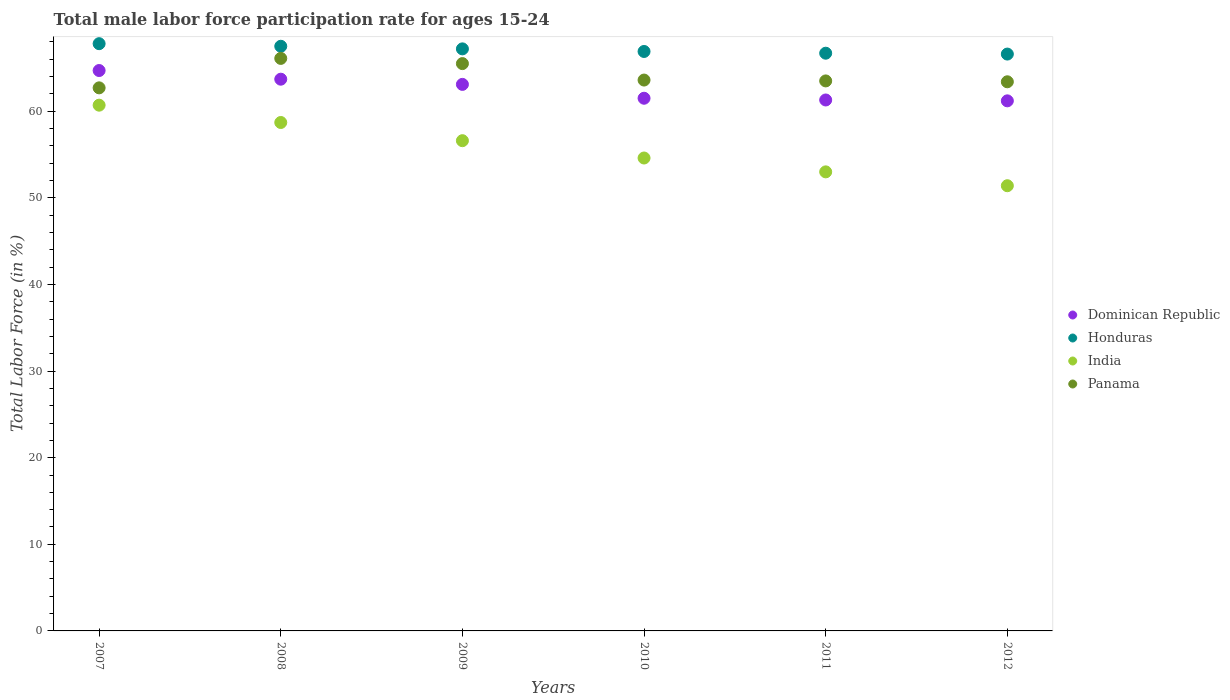How many different coloured dotlines are there?
Your response must be concise. 4. What is the male labor force participation rate in Panama in 2010?
Provide a short and direct response. 63.6. Across all years, what is the maximum male labor force participation rate in Dominican Republic?
Offer a very short reply. 64.7. Across all years, what is the minimum male labor force participation rate in Honduras?
Your answer should be compact. 66.6. In which year was the male labor force participation rate in Honduras maximum?
Offer a terse response. 2007. In which year was the male labor force participation rate in Dominican Republic minimum?
Your answer should be compact. 2012. What is the total male labor force participation rate in Panama in the graph?
Offer a very short reply. 384.8. What is the difference between the male labor force participation rate in Honduras in 2009 and that in 2010?
Your answer should be compact. 0.3. What is the difference between the male labor force participation rate in India in 2009 and the male labor force participation rate in Honduras in 2007?
Make the answer very short. -11.2. What is the average male labor force participation rate in Dominican Republic per year?
Provide a short and direct response. 62.58. In the year 2011, what is the difference between the male labor force participation rate in India and male labor force participation rate in Honduras?
Offer a very short reply. -13.7. In how many years, is the male labor force participation rate in Dominican Republic greater than 6 %?
Keep it short and to the point. 6. What is the ratio of the male labor force participation rate in Dominican Republic in 2008 to that in 2011?
Make the answer very short. 1.04. Is the male labor force participation rate in Dominican Republic in 2007 less than that in 2012?
Offer a very short reply. No. Is the difference between the male labor force participation rate in India in 2008 and 2012 greater than the difference between the male labor force participation rate in Honduras in 2008 and 2012?
Provide a short and direct response. Yes. What is the difference between the highest and the second highest male labor force participation rate in India?
Keep it short and to the point. 2. What is the difference between the highest and the lowest male labor force participation rate in Dominican Republic?
Give a very brief answer. 3.5. In how many years, is the male labor force participation rate in Honduras greater than the average male labor force participation rate in Honduras taken over all years?
Keep it short and to the point. 3. Does the male labor force participation rate in Panama monotonically increase over the years?
Offer a terse response. No. Is the male labor force participation rate in India strictly greater than the male labor force participation rate in Panama over the years?
Provide a succinct answer. No. How many years are there in the graph?
Keep it short and to the point. 6. What is the difference between two consecutive major ticks on the Y-axis?
Give a very brief answer. 10. Are the values on the major ticks of Y-axis written in scientific E-notation?
Offer a very short reply. No. Does the graph contain any zero values?
Make the answer very short. No. Does the graph contain grids?
Provide a short and direct response. No. Where does the legend appear in the graph?
Give a very brief answer. Center right. How many legend labels are there?
Your answer should be very brief. 4. What is the title of the graph?
Keep it short and to the point. Total male labor force participation rate for ages 15-24. What is the label or title of the Y-axis?
Offer a very short reply. Total Labor Force (in %). What is the Total Labor Force (in %) of Dominican Republic in 2007?
Keep it short and to the point. 64.7. What is the Total Labor Force (in %) in Honduras in 2007?
Keep it short and to the point. 67.8. What is the Total Labor Force (in %) of India in 2007?
Make the answer very short. 60.7. What is the Total Labor Force (in %) of Panama in 2007?
Your answer should be very brief. 62.7. What is the Total Labor Force (in %) of Dominican Republic in 2008?
Offer a very short reply. 63.7. What is the Total Labor Force (in %) in Honduras in 2008?
Give a very brief answer. 67.5. What is the Total Labor Force (in %) in India in 2008?
Give a very brief answer. 58.7. What is the Total Labor Force (in %) in Panama in 2008?
Your answer should be very brief. 66.1. What is the Total Labor Force (in %) in Dominican Republic in 2009?
Your answer should be very brief. 63.1. What is the Total Labor Force (in %) of Honduras in 2009?
Keep it short and to the point. 67.2. What is the Total Labor Force (in %) of India in 2009?
Your response must be concise. 56.6. What is the Total Labor Force (in %) of Panama in 2009?
Make the answer very short. 65.5. What is the Total Labor Force (in %) of Dominican Republic in 2010?
Offer a very short reply. 61.5. What is the Total Labor Force (in %) of Honduras in 2010?
Your answer should be very brief. 66.9. What is the Total Labor Force (in %) in India in 2010?
Provide a succinct answer. 54.6. What is the Total Labor Force (in %) in Panama in 2010?
Your answer should be compact. 63.6. What is the Total Labor Force (in %) in Dominican Republic in 2011?
Offer a terse response. 61.3. What is the Total Labor Force (in %) of Honduras in 2011?
Keep it short and to the point. 66.7. What is the Total Labor Force (in %) of India in 2011?
Give a very brief answer. 53. What is the Total Labor Force (in %) in Panama in 2011?
Provide a short and direct response. 63.5. What is the Total Labor Force (in %) of Dominican Republic in 2012?
Your response must be concise. 61.2. What is the Total Labor Force (in %) of Honduras in 2012?
Make the answer very short. 66.6. What is the Total Labor Force (in %) of India in 2012?
Ensure brevity in your answer.  51.4. What is the Total Labor Force (in %) in Panama in 2012?
Offer a very short reply. 63.4. Across all years, what is the maximum Total Labor Force (in %) of Dominican Republic?
Ensure brevity in your answer.  64.7. Across all years, what is the maximum Total Labor Force (in %) in Honduras?
Offer a terse response. 67.8. Across all years, what is the maximum Total Labor Force (in %) in India?
Keep it short and to the point. 60.7. Across all years, what is the maximum Total Labor Force (in %) in Panama?
Provide a short and direct response. 66.1. Across all years, what is the minimum Total Labor Force (in %) in Dominican Republic?
Provide a short and direct response. 61.2. Across all years, what is the minimum Total Labor Force (in %) in Honduras?
Give a very brief answer. 66.6. Across all years, what is the minimum Total Labor Force (in %) in India?
Provide a succinct answer. 51.4. Across all years, what is the minimum Total Labor Force (in %) of Panama?
Ensure brevity in your answer.  62.7. What is the total Total Labor Force (in %) in Dominican Republic in the graph?
Your answer should be very brief. 375.5. What is the total Total Labor Force (in %) in Honduras in the graph?
Your response must be concise. 402.7. What is the total Total Labor Force (in %) in India in the graph?
Your answer should be very brief. 335. What is the total Total Labor Force (in %) of Panama in the graph?
Your answer should be compact. 384.8. What is the difference between the Total Labor Force (in %) in Honduras in 2007 and that in 2008?
Your answer should be very brief. 0.3. What is the difference between the Total Labor Force (in %) in Honduras in 2007 and that in 2009?
Keep it short and to the point. 0.6. What is the difference between the Total Labor Force (in %) in Panama in 2007 and that in 2009?
Give a very brief answer. -2.8. What is the difference between the Total Labor Force (in %) in Dominican Republic in 2007 and that in 2010?
Provide a short and direct response. 3.2. What is the difference between the Total Labor Force (in %) of Honduras in 2007 and that in 2010?
Ensure brevity in your answer.  0.9. What is the difference between the Total Labor Force (in %) in Panama in 2007 and that in 2010?
Give a very brief answer. -0.9. What is the difference between the Total Labor Force (in %) of Dominican Republic in 2007 and that in 2011?
Give a very brief answer. 3.4. What is the difference between the Total Labor Force (in %) in India in 2007 and that in 2011?
Give a very brief answer. 7.7. What is the difference between the Total Labor Force (in %) in Panama in 2007 and that in 2011?
Keep it short and to the point. -0.8. What is the difference between the Total Labor Force (in %) of Dominican Republic in 2007 and that in 2012?
Offer a terse response. 3.5. What is the difference between the Total Labor Force (in %) in Honduras in 2007 and that in 2012?
Your response must be concise. 1.2. What is the difference between the Total Labor Force (in %) of India in 2007 and that in 2012?
Your response must be concise. 9.3. What is the difference between the Total Labor Force (in %) of Panama in 2007 and that in 2012?
Give a very brief answer. -0.7. What is the difference between the Total Labor Force (in %) of Honduras in 2008 and that in 2009?
Offer a very short reply. 0.3. What is the difference between the Total Labor Force (in %) in India in 2008 and that in 2009?
Your answer should be compact. 2.1. What is the difference between the Total Labor Force (in %) in Dominican Republic in 2008 and that in 2010?
Offer a terse response. 2.2. What is the difference between the Total Labor Force (in %) in India in 2008 and that in 2010?
Keep it short and to the point. 4.1. What is the difference between the Total Labor Force (in %) in Panama in 2008 and that in 2010?
Ensure brevity in your answer.  2.5. What is the difference between the Total Labor Force (in %) in Honduras in 2008 and that in 2011?
Your response must be concise. 0.8. What is the difference between the Total Labor Force (in %) in India in 2008 and that in 2011?
Offer a terse response. 5.7. What is the difference between the Total Labor Force (in %) in Panama in 2008 and that in 2011?
Ensure brevity in your answer.  2.6. What is the difference between the Total Labor Force (in %) of Dominican Republic in 2008 and that in 2012?
Keep it short and to the point. 2.5. What is the difference between the Total Labor Force (in %) of Panama in 2008 and that in 2012?
Give a very brief answer. 2.7. What is the difference between the Total Labor Force (in %) of Dominican Republic in 2009 and that in 2010?
Provide a succinct answer. 1.6. What is the difference between the Total Labor Force (in %) of India in 2009 and that in 2010?
Your answer should be compact. 2. What is the difference between the Total Labor Force (in %) of Dominican Republic in 2009 and that in 2011?
Make the answer very short. 1.8. What is the difference between the Total Labor Force (in %) of Dominican Republic in 2009 and that in 2012?
Provide a short and direct response. 1.9. What is the difference between the Total Labor Force (in %) in Honduras in 2009 and that in 2012?
Provide a short and direct response. 0.6. What is the difference between the Total Labor Force (in %) in India in 2009 and that in 2012?
Make the answer very short. 5.2. What is the difference between the Total Labor Force (in %) in Panama in 2009 and that in 2012?
Provide a short and direct response. 2.1. What is the difference between the Total Labor Force (in %) in Honduras in 2010 and that in 2011?
Make the answer very short. 0.2. What is the difference between the Total Labor Force (in %) of Dominican Republic in 2010 and that in 2012?
Offer a terse response. 0.3. What is the difference between the Total Labor Force (in %) of Honduras in 2010 and that in 2012?
Provide a short and direct response. 0.3. What is the difference between the Total Labor Force (in %) in India in 2010 and that in 2012?
Provide a short and direct response. 3.2. What is the difference between the Total Labor Force (in %) of Panama in 2010 and that in 2012?
Your response must be concise. 0.2. What is the difference between the Total Labor Force (in %) in Panama in 2011 and that in 2012?
Give a very brief answer. 0.1. What is the difference between the Total Labor Force (in %) in Dominican Republic in 2007 and the Total Labor Force (in %) in Honduras in 2008?
Offer a terse response. -2.8. What is the difference between the Total Labor Force (in %) of Honduras in 2007 and the Total Labor Force (in %) of India in 2008?
Ensure brevity in your answer.  9.1. What is the difference between the Total Labor Force (in %) of Honduras in 2007 and the Total Labor Force (in %) of Panama in 2008?
Offer a very short reply. 1.7. What is the difference between the Total Labor Force (in %) of Dominican Republic in 2007 and the Total Labor Force (in %) of India in 2009?
Your response must be concise. 8.1. What is the difference between the Total Labor Force (in %) of Honduras in 2007 and the Total Labor Force (in %) of India in 2009?
Provide a succinct answer. 11.2. What is the difference between the Total Labor Force (in %) of India in 2007 and the Total Labor Force (in %) of Panama in 2009?
Provide a short and direct response. -4.8. What is the difference between the Total Labor Force (in %) of Dominican Republic in 2007 and the Total Labor Force (in %) of Panama in 2010?
Your answer should be very brief. 1.1. What is the difference between the Total Labor Force (in %) of Honduras in 2007 and the Total Labor Force (in %) of India in 2010?
Offer a very short reply. 13.2. What is the difference between the Total Labor Force (in %) of India in 2007 and the Total Labor Force (in %) of Panama in 2010?
Make the answer very short. -2.9. What is the difference between the Total Labor Force (in %) of Honduras in 2007 and the Total Labor Force (in %) of India in 2011?
Offer a terse response. 14.8. What is the difference between the Total Labor Force (in %) of India in 2007 and the Total Labor Force (in %) of Panama in 2011?
Give a very brief answer. -2.8. What is the difference between the Total Labor Force (in %) in Dominican Republic in 2007 and the Total Labor Force (in %) in Honduras in 2012?
Provide a short and direct response. -1.9. What is the difference between the Total Labor Force (in %) in Honduras in 2007 and the Total Labor Force (in %) in Panama in 2012?
Your answer should be very brief. 4.4. What is the difference between the Total Labor Force (in %) in India in 2007 and the Total Labor Force (in %) in Panama in 2012?
Ensure brevity in your answer.  -2.7. What is the difference between the Total Labor Force (in %) in Dominican Republic in 2008 and the Total Labor Force (in %) in India in 2009?
Make the answer very short. 7.1. What is the difference between the Total Labor Force (in %) in Honduras in 2008 and the Total Labor Force (in %) in India in 2009?
Offer a very short reply. 10.9. What is the difference between the Total Labor Force (in %) of Honduras in 2008 and the Total Labor Force (in %) of Panama in 2009?
Provide a short and direct response. 2. What is the difference between the Total Labor Force (in %) in Honduras in 2008 and the Total Labor Force (in %) in Panama in 2010?
Give a very brief answer. 3.9. What is the difference between the Total Labor Force (in %) of India in 2008 and the Total Labor Force (in %) of Panama in 2010?
Your answer should be very brief. -4.9. What is the difference between the Total Labor Force (in %) of Dominican Republic in 2008 and the Total Labor Force (in %) of India in 2011?
Your response must be concise. 10.7. What is the difference between the Total Labor Force (in %) of Dominican Republic in 2008 and the Total Labor Force (in %) of Panama in 2011?
Ensure brevity in your answer.  0.2. What is the difference between the Total Labor Force (in %) in Honduras in 2008 and the Total Labor Force (in %) in India in 2011?
Keep it short and to the point. 14.5. What is the difference between the Total Labor Force (in %) in Dominican Republic in 2008 and the Total Labor Force (in %) in India in 2012?
Give a very brief answer. 12.3. What is the difference between the Total Labor Force (in %) in Honduras in 2008 and the Total Labor Force (in %) in India in 2012?
Provide a succinct answer. 16.1. What is the difference between the Total Labor Force (in %) of Dominican Republic in 2009 and the Total Labor Force (in %) of Panama in 2010?
Your answer should be compact. -0.5. What is the difference between the Total Labor Force (in %) of Honduras in 2009 and the Total Labor Force (in %) of India in 2010?
Your response must be concise. 12.6. What is the difference between the Total Labor Force (in %) in Honduras in 2009 and the Total Labor Force (in %) in Panama in 2010?
Keep it short and to the point. 3.6. What is the difference between the Total Labor Force (in %) in India in 2009 and the Total Labor Force (in %) in Panama in 2010?
Your answer should be very brief. -7. What is the difference between the Total Labor Force (in %) of Dominican Republic in 2009 and the Total Labor Force (in %) of India in 2011?
Make the answer very short. 10.1. What is the difference between the Total Labor Force (in %) in Dominican Republic in 2009 and the Total Labor Force (in %) in Panama in 2011?
Provide a succinct answer. -0.4. What is the difference between the Total Labor Force (in %) of Honduras in 2009 and the Total Labor Force (in %) of India in 2011?
Keep it short and to the point. 14.2. What is the difference between the Total Labor Force (in %) of Dominican Republic in 2009 and the Total Labor Force (in %) of Honduras in 2012?
Your response must be concise. -3.5. What is the difference between the Total Labor Force (in %) in Dominican Republic in 2009 and the Total Labor Force (in %) in Panama in 2012?
Provide a succinct answer. -0.3. What is the difference between the Total Labor Force (in %) of Honduras in 2009 and the Total Labor Force (in %) of Panama in 2012?
Give a very brief answer. 3.8. What is the difference between the Total Labor Force (in %) of India in 2009 and the Total Labor Force (in %) of Panama in 2012?
Your answer should be compact. -6.8. What is the difference between the Total Labor Force (in %) in Dominican Republic in 2010 and the Total Labor Force (in %) in India in 2011?
Provide a succinct answer. 8.5. What is the difference between the Total Labor Force (in %) of Honduras in 2010 and the Total Labor Force (in %) of India in 2011?
Your response must be concise. 13.9. What is the difference between the Total Labor Force (in %) in Honduras in 2010 and the Total Labor Force (in %) in Panama in 2011?
Provide a short and direct response. 3.4. What is the difference between the Total Labor Force (in %) in Dominican Republic in 2010 and the Total Labor Force (in %) in India in 2012?
Offer a very short reply. 10.1. What is the difference between the Total Labor Force (in %) of India in 2010 and the Total Labor Force (in %) of Panama in 2012?
Your answer should be very brief. -8.8. What is the difference between the Total Labor Force (in %) of Dominican Republic in 2011 and the Total Labor Force (in %) of Honduras in 2012?
Your answer should be very brief. -5.3. What is the difference between the Total Labor Force (in %) of Dominican Republic in 2011 and the Total Labor Force (in %) of India in 2012?
Offer a terse response. 9.9. What is the difference between the Total Labor Force (in %) of Dominican Republic in 2011 and the Total Labor Force (in %) of Panama in 2012?
Give a very brief answer. -2.1. What is the difference between the Total Labor Force (in %) of India in 2011 and the Total Labor Force (in %) of Panama in 2012?
Provide a short and direct response. -10.4. What is the average Total Labor Force (in %) in Dominican Republic per year?
Keep it short and to the point. 62.58. What is the average Total Labor Force (in %) of Honduras per year?
Keep it short and to the point. 67.12. What is the average Total Labor Force (in %) of India per year?
Your response must be concise. 55.83. What is the average Total Labor Force (in %) of Panama per year?
Your response must be concise. 64.13. In the year 2007, what is the difference between the Total Labor Force (in %) in Dominican Republic and Total Labor Force (in %) in Panama?
Your response must be concise. 2. In the year 2007, what is the difference between the Total Labor Force (in %) of Honduras and Total Labor Force (in %) of India?
Your answer should be very brief. 7.1. In the year 2008, what is the difference between the Total Labor Force (in %) of Dominican Republic and Total Labor Force (in %) of Honduras?
Provide a short and direct response. -3.8. In the year 2008, what is the difference between the Total Labor Force (in %) in Dominican Republic and Total Labor Force (in %) in Panama?
Ensure brevity in your answer.  -2.4. In the year 2008, what is the difference between the Total Labor Force (in %) of Honduras and Total Labor Force (in %) of India?
Provide a succinct answer. 8.8. In the year 2008, what is the difference between the Total Labor Force (in %) of India and Total Labor Force (in %) of Panama?
Give a very brief answer. -7.4. In the year 2009, what is the difference between the Total Labor Force (in %) in Dominican Republic and Total Labor Force (in %) in Honduras?
Your answer should be compact. -4.1. In the year 2009, what is the difference between the Total Labor Force (in %) in Dominican Republic and Total Labor Force (in %) in India?
Your answer should be very brief. 6.5. In the year 2009, what is the difference between the Total Labor Force (in %) in Dominican Republic and Total Labor Force (in %) in Panama?
Keep it short and to the point. -2.4. In the year 2009, what is the difference between the Total Labor Force (in %) in Honduras and Total Labor Force (in %) in Panama?
Make the answer very short. 1.7. In the year 2009, what is the difference between the Total Labor Force (in %) in India and Total Labor Force (in %) in Panama?
Make the answer very short. -8.9. In the year 2010, what is the difference between the Total Labor Force (in %) in Dominican Republic and Total Labor Force (in %) in Honduras?
Provide a short and direct response. -5.4. In the year 2010, what is the difference between the Total Labor Force (in %) in Dominican Republic and Total Labor Force (in %) in India?
Ensure brevity in your answer.  6.9. In the year 2010, what is the difference between the Total Labor Force (in %) of Dominican Republic and Total Labor Force (in %) of Panama?
Give a very brief answer. -2.1. In the year 2010, what is the difference between the Total Labor Force (in %) in Honduras and Total Labor Force (in %) in India?
Offer a very short reply. 12.3. In the year 2010, what is the difference between the Total Labor Force (in %) of India and Total Labor Force (in %) of Panama?
Give a very brief answer. -9. In the year 2011, what is the difference between the Total Labor Force (in %) of Honduras and Total Labor Force (in %) of India?
Your answer should be compact. 13.7. In the year 2011, what is the difference between the Total Labor Force (in %) in India and Total Labor Force (in %) in Panama?
Offer a terse response. -10.5. In the year 2012, what is the difference between the Total Labor Force (in %) in Dominican Republic and Total Labor Force (in %) in Honduras?
Offer a very short reply. -5.4. In the year 2012, what is the difference between the Total Labor Force (in %) of Dominican Republic and Total Labor Force (in %) of Panama?
Your answer should be very brief. -2.2. What is the ratio of the Total Labor Force (in %) in Dominican Republic in 2007 to that in 2008?
Ensure brevity in your answer.  1.02. What is the ratio of the Total Labor Force (in %) in Honduras in 2007 to that in 2008?
Your response must be concise. 1. What is the ratio of the Total Labor Force (in %) of India in 2007 to that in 2008?
Provide a succinct answer. 1.03. What is the ratio of the Total Labor Force (in %) of Panama in 2007 to that in 2008?
Make the answer very short. 0.95. What is the ratio of the Total Labor Force (in %) of Dominican Republic in 2007 to that in 2009?
Make the answer very short. 1.03. What is the ratio of the Total Labor Force (in %) in Honduras in 2007 to that in 2009?
Offer a terse response. 1.01. What is the ratio of the Total Labor Force (in %) of India in 2007 to that in 2009?
Offer a very short reply. 1.07. What is the ratio of the Total Labor Force (in %) of Panama in 2007 to that in 2009?
Your response must be concise. 0.96. What is the ratio of the Total Labor Force (in %) in Dominican Republic in 2007 to that in 2010?
Make the answer very short. 1.05. What is the ratio of the Total Labor Force (in %) in Honduras in 2007 to that in 2010?
Provide a succinct answer. 1.01. What is the ratio of the Total Labor Force (in %) in India in 2007 to that in 2010?
Give a very brief answer. 1.11. What is the ratio of the Total Labor Force (in %) in Panama in 2007 to that in 2010?
Keep it short and to the point. 0.99. What is the ratio of the Total Labor Force (in %) of Dominican Republic in 2007 to that in 2011?
Your answer should be very brief. 1.06. What is the ratio of the Total Labor Force (in %) of Honduras in 2007 to that in 2011?
Offer a terse response. 1.02. What is the ratio of the Total Labor Force (in %) of India in 2007 to that in 2011?
Provide a succinct answer. 1.15. What is the ratio of the Total Labor Force (in %) in Panama in 2007 to that in 2011?
Provide a succinct answer. 0.99. What is the ratio of the Total Labor Force (in %) of Dominican Republic in 2007 to that in 2012?
Make the answer very short. 1.06. What is the ratio of the Total Labor Force (in %) of India in 2007 to that in 2012?
Offer a very short reply. 1.18. What is the ratio of the Total Labor Force (in %) of Dominican Republic in 2008 to that in 2009?
Provide a succinct answer. 1.01. What is the ratio of the Total Labor Force (in %) of Honduras in 2008 to that in 2009?
Your answer should be compact. 1. What is the ratio of the Total Labor Force (in %) of India in 2008 to that in 2009?
Your answer should be very brief. 1.04. What is the ratio of the Total Labor Force (in %) of Panama in 2008 to that in 2009?
Provide a short and direct response. 1.01. What is the ratio of the Total Labor Force (in %) of Dominican Republic in 2008 to that in 2010?
Make the answer very short. 1.04. What is the ratio of the Total Labor Force (in %) of Honduras in 2008 to that in 2010?
Ensure brevity in your answer.  1.01. What is the ratio of the Total Labor Force (in %) of India in 2008 to that in 2010?
Offer a very short reply. 1.08. What is the ratio of the Total Labor Force (in %) in Panama in 2008 to that in 2010?
Provide a succinct answer. 1.04. What is the ratio of the Total Labor Force (in %) of Dominican Republic in 2008 to that in 2011?
Keep it short and to the point. 1.04. What is the ratio of the Total Labor Force (in %) in India in 2008 to that in 2011?
Ensure brevity in your answer.  1.11. What is the ratio of the Total Labor Force (in %) in Panama in 2008 to that in 2011?
Keep it short and to the point. 1.04. What is the ratio of the Total Labor Force (in %) in Dominican Republic in 2008 to that in 2012?
Give a very brief answer. 1.04. What is the ratio of the Total Labor Force (in %) in Honduras in 2008 to that in 2012?
Provide a succinct answer. 1.01. What is the ratio of the Total Labor Force (in %) in India in 2008 to that in 2012?
Offer a very short reply. 1.14. What is the ratio of the Total Labor Force (in %) of Panama in 2008 to that in 2012?
Your answer should be compact. 1.04. What is the ratio of the Total Labor Force (in %) in Dominican Republic in 2009 to that in 2010?
Your response must be concise. 1.03. What is the ratio of the Total Labor Force (in %) in Honduras in 2009 to that in 2010?
Keep it short and to the point. 1. What is the ratio of the Total Labor Force (in %) of India in 2009 to that in 2010?
Your answer should be compact. 1.04. What is the ratio of the Total Labor Force (in %) in Panama in 2009 to that in 2010?
Keep it short and to the point. 1.03. What is the ratio of the Total Labor Force (in %) of Dominican Republic in 2009 to that in 2011?
Your answer should be very brief. 1.03. What is the ratio of the Total Labor Force (in %) of Honduras in 2009 to that in 2011?
Offer a terse response. 1.01. What is the ratio of the Total Labor Force (in %) of India in 2009 to that in 2011?
Make the answer very short. 1.07. What is the ratio of the Total Labor Force (in %) of Panama in 2009 to that in 2011?
Your response must be concise. 1.03. What is the ratio of the Total Labor Force (in %) in Dominican Republic in 2009 to that in 2012?
Provide a succinct answer. 1.03. What is the ratio of the Total Labor Force (in %) of India in 2009 to that in 2012?
Your answer should be very brief. 1.1. What is the ratio of the Total Labor Force (in %) of Panama in 2009 to that in 2012?
Offer a terse response. 1.03. What is the ratio of the Total Labor Force (in %) in Dominican Republic in 2010 to that in 2011?
Make the answer very short. 1. What is the ratio of the Total Labor Force (in %) in Honduras in 2010 to that in 2011?
Provide a succinct answer. 1. What is the ratio of the Total Labor Force (in %) in India in 2010 to that in 2011?
Your answer should be compact. 1.03. What is the ratio of the Total Labor Force (in %) in Panama in 2010 to that in 2011?
Provide a succinct answer. 1. What is the ratio of the Total Labor Force (in %) in Dominican Republic in 2010 to that in 2012?
Keep it short and to the point. 1. What is the ratio of the Total Labor Force (in %) in Honduras in 2010 to that in 2012?
Offer a very short reply. 1. What is the ratio of the Total Labor Force (in %) in India in 2010 to that in 2012?
Make the answer very short. 1.06. What is the ratio of the Total Labor Force (in %) in India in 2011 to that in 2012?
Offer a terse response. 1.03. What is the ratio of the Total Labor Force (in %) of Panama in 2011 to that in 2012?
Ensure brevity in your answer.  1. What is the difference between the highest and the second highest Total Labor Force (in %) of Honduras?
Offer a very short reply. 0.3. What is the difference between the highest and the second highest Total Labor Force (in %) of India?
Provide a short and direct response. 2. What is the difference between the highest and the lowest Total Labor Force (in %) of Dominican Republic?
Your answer should be compact. 3.5. What is the difference between the highest and the lowest Total Labor Force (in %) in India?
Give a very brief answer. 9.3. 